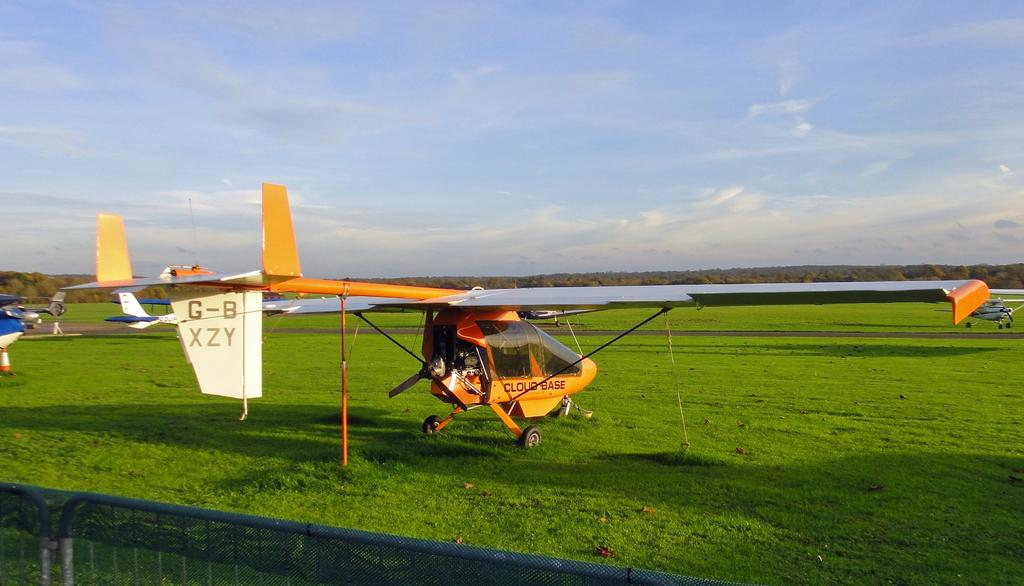What is located on the grass path in the image? There are aircrafts on the grass path in the image. What is placed behind the aircrafts to separate them from other areas? There are barriers with a net behind the aircrafts. What type of natural scenery is visible in front of the aircrafts? Trees are visible in front of the aircrafts. What part of the natural environment is visible in the image? The sky is visible in the image. What type of protest is taking place in the image? There is no protest present in the image; it features aircrafts on a grass path with barriers, trees, and the sky visible. What song is being sung by the cup in the image? There is no cup or singing in the image; it only features aircrafts, barriers, trees, and the sky. 